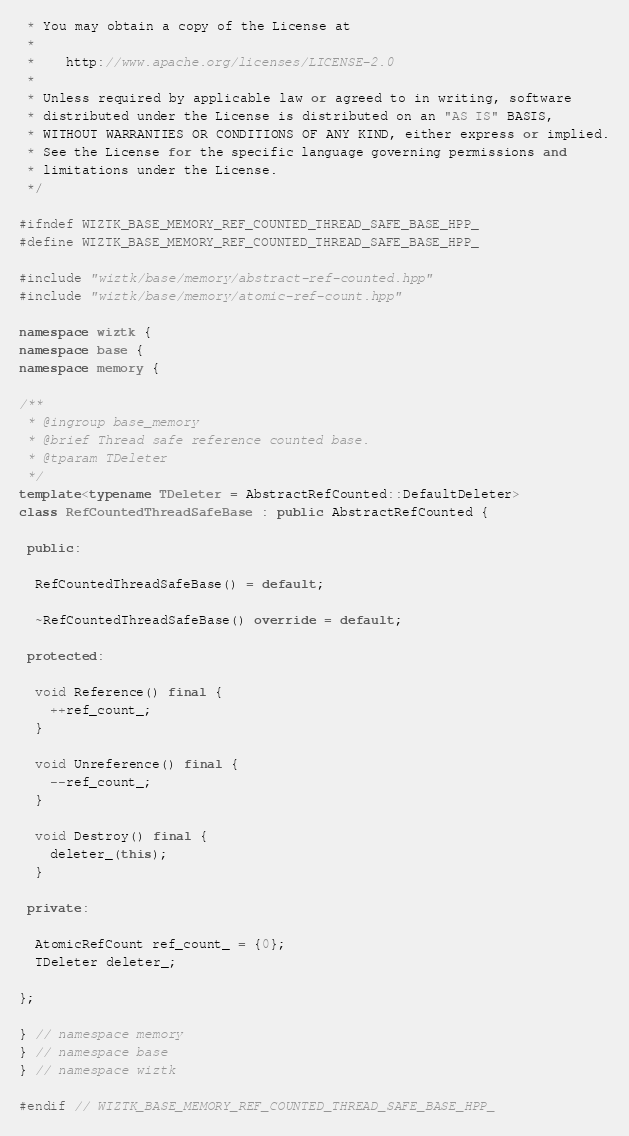<code> <loc_0><loc_0><loc_500><loc_500><_C++_> * You may obtain a copy of the License at
 *
 *    http://www.apache.org/licenses/LICENSE-2.0
 *
 * Unless required by applicable law or agreed to in writing, software
 * distributed under the License is distributed on an "AS IS" BASIS,
 * WITHOUT WARRANTIES OR CONDITIONS OF ANY KIND, either express or implied.
 * See the License for the specific language governing permissions and
 * limitations under the License.
 */

#ifndef WIZTK_BASE_MEMORY_REF_COUNTED_THREAD_SAFE_BASE_HPP_
#define WIZTK_BASE_MEMORY_REF_COUNTED_THREAD_SAFE_BASE_HPP_

#include "wiztk/base/memory/abstract-ref-counted.hpp"
#include "wiztk/base/memory/atomic-ref-count.hpp"

namespace wiztk {
namespace base {
namespace memory {

/**
 * @ingroup base_memory
 * @brief Thread safe reference counted base.
 * @tparam TDeleter
 */
template<typename TDeleter = AbstractRefCounted::DefaultDeleter>
class RefCountedThreadSafeBase : public AbstractRefCounted {

 public:

  RefCountedThreadSafeBase() = default;

  ~RefCountedThreadSafeBase() override = default;

 protected:

  void Reference() final {
    ++ref_count_;
  }

  void Unreference() final {
    --ref_count_;
  }

  void Destroy() final {
    deleter_(this);
  }

 private:

  AtomicRefCount ref_count_ = {0};
  TDeleter deleter_;

};

} // namespace memory
} // namespace base
} // namespace wiztk

#endif // WIZTK_BASE_MEMORY_REF_COUNTED_THREAD_SAFE_BASE_HPP_
</code> 